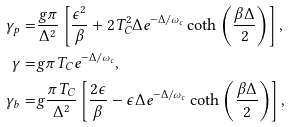Convert formula to latex. <formula><loc_0><loc_0><loc_500><loc_500>\gamma _ { p } = & \frac { g \pi } { \Delta ^ { 2 } } \left [ \frac { \epsilon ^ { 2 } } { \beta } + 2 T _ { C } ^ { 2 } \Delta e ^ { - \Delta / \omega _ { c } } \coth { \left ( \frac { \beta \Delta } { 2 } \right ) } \right ] , \\ \gamma = & g \pi T _ { C } e ^ { - \Delta / \omega _ { c } } , \\ \gamma _ { b } = & g \frac { \pi T _ { C } } { \Delta ^ { 2 } } \left [ \frac { 2 \epsilon } { \beta } - \epsilon \Delta e ^ { - \Delta / \omega _ { c } } \coth \left ( \frac { \beta \Delta } { 2 } \right ) \right ] ,</formula> 